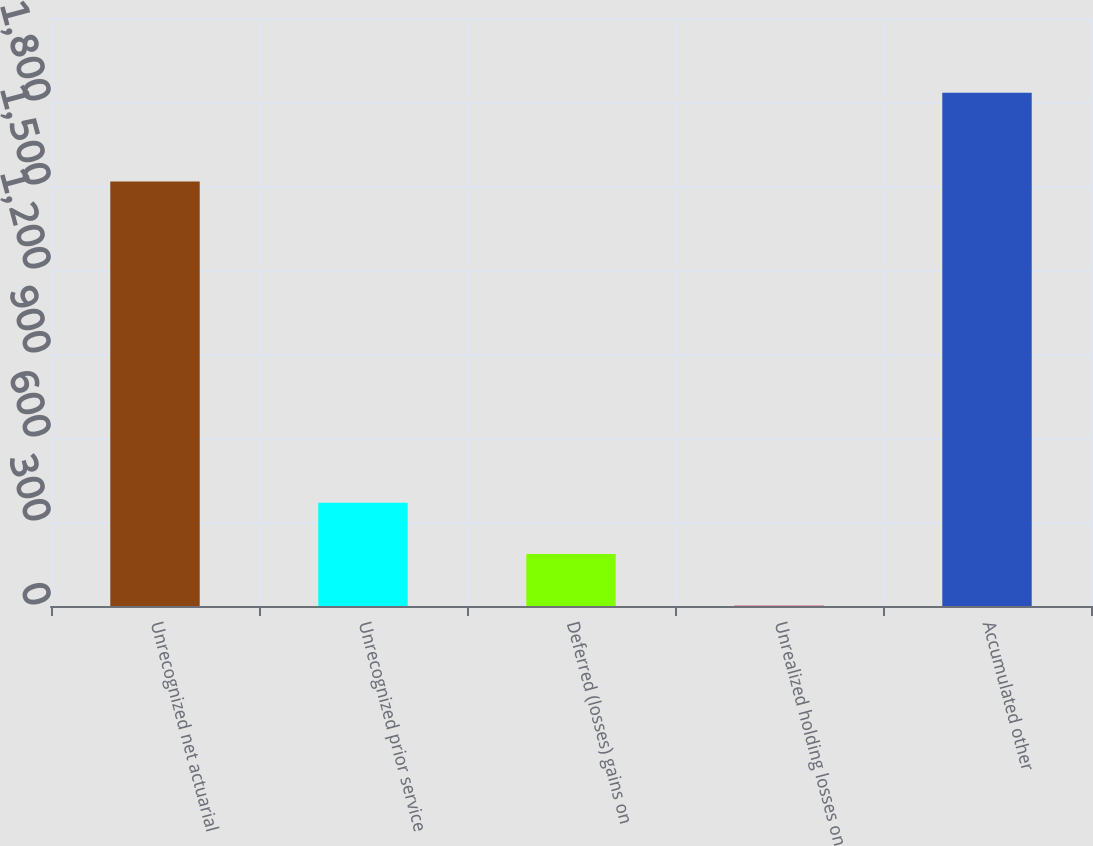Convert chart to OTSL. <chart><loc_0><loc_0><loc_500><loc_500><bar_chart><fcel>Unrecognized net actuarial<fcel>Unrecognized prior service<fcel>Deferred (losses) gains on<fcel>Unrealized holding losses on<fcel>Accumulated other<nl><fcel>1516<fcel>369<fcel>186<fcel>3<fcel>1833<nl></chart> 